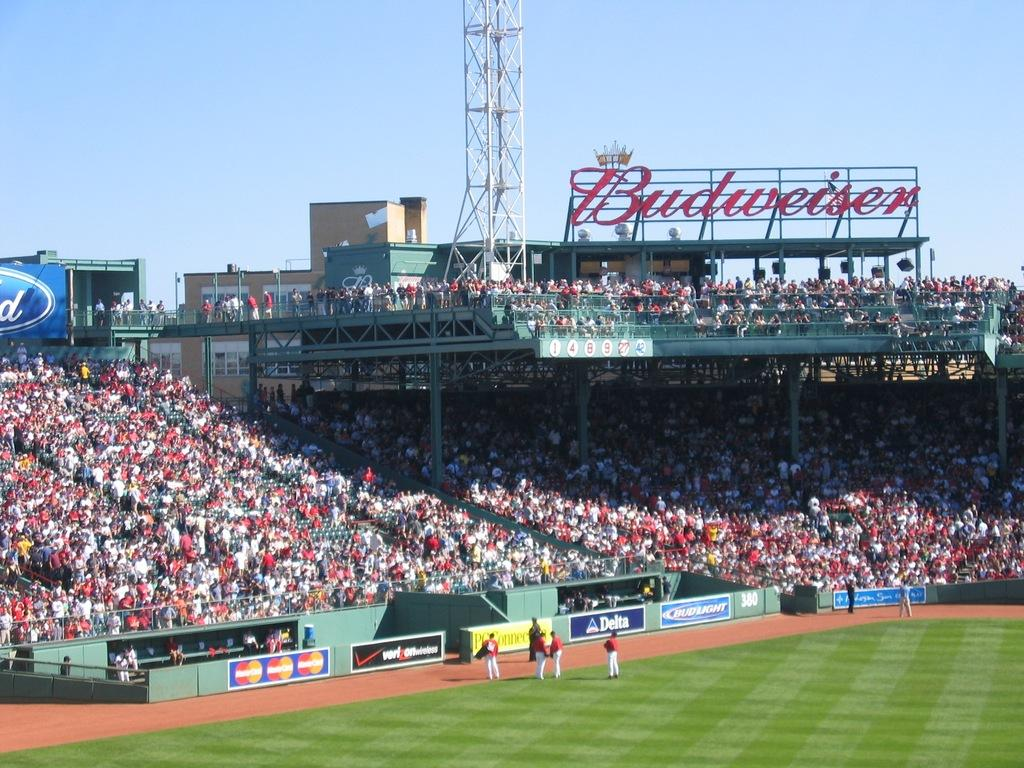<image>
Create a compact narrative representing the image presented. A large Budweiser sign hangs over a baseball field. 